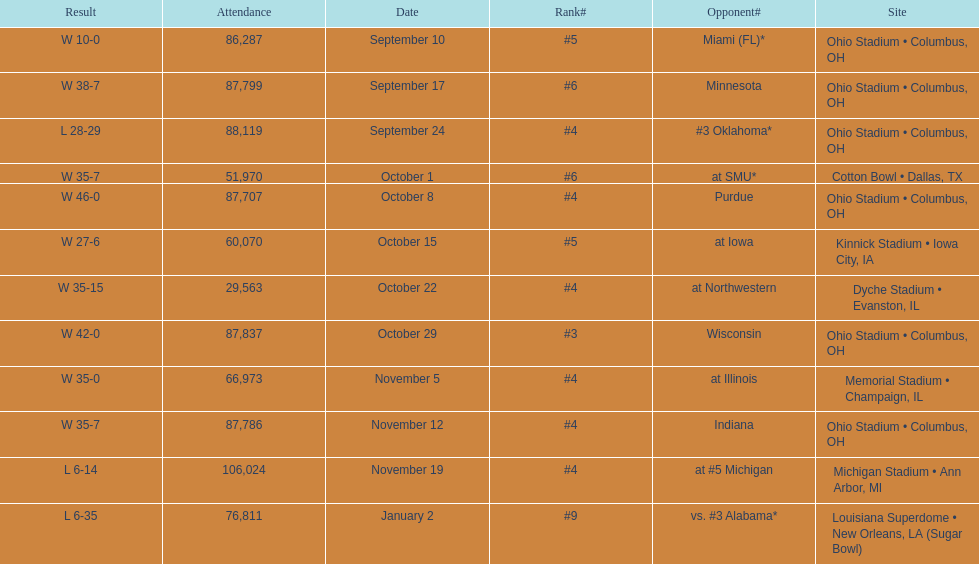Which date was attended by the most people? November 19. 